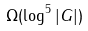Convert formula to latex. <formula><loc_0><loc_0><loc_500><loc_500>\Omega ( \log ^ { 5 } | G | )</formula> 